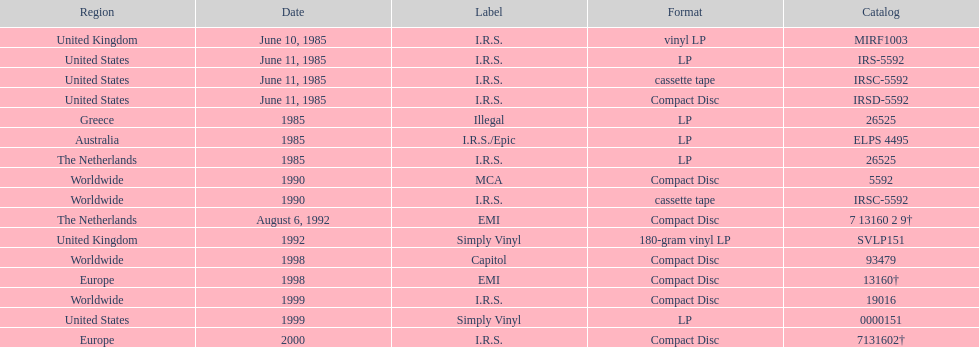How many more releases were in compact disc format than cassette tape? 5. 